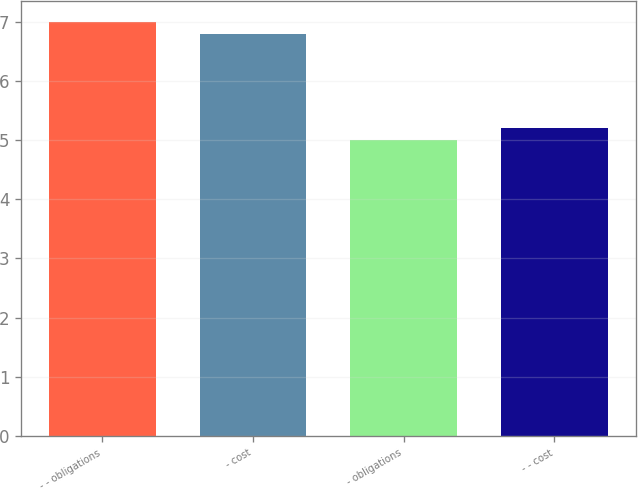<chart> <loc_0><loc_0><loc_500><loc_500><bar_chart><fcel>- - obligations<fcel>- cost<fcel>- obligations<fcel>- - cost<nl><fcel>7<fcel>6.8<fcel>5<fcel>5.2<nl></chart> 